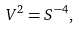<formula> <loc_0><loc_0><loc_500><loc_500>V ^ { 2 } = S ^ { - 4 } ,</formula> 